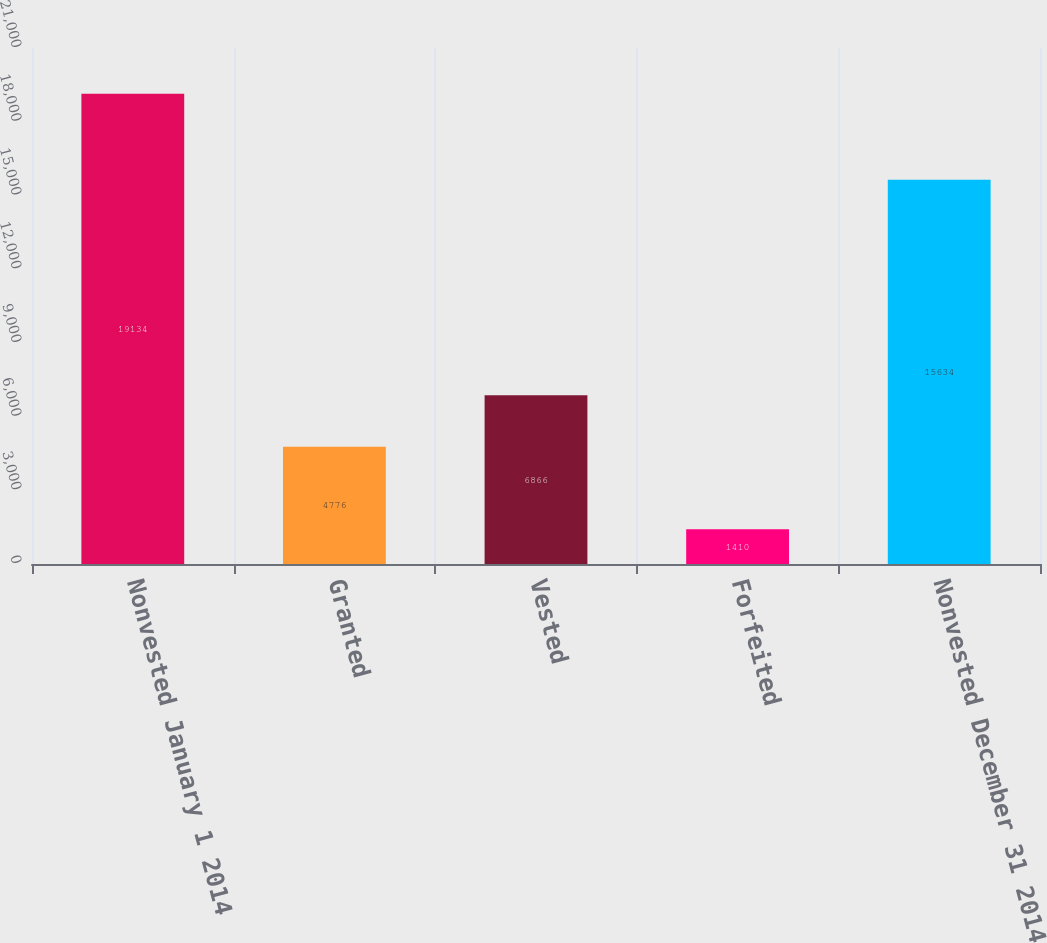Convert chart to OTSL. <chart><loc_0><loc_0><loc_500><loc_500><bar_chart><fcel>Nonvested January 1 2014<fcel>Granted<fcel>Vested<fcel>Forfeited<fcel>Nonvested December 31 2014<nl><fcel>19134<fcel>4776<fcel>6866<fcel>1410<fcel>15634<nl></chart> 